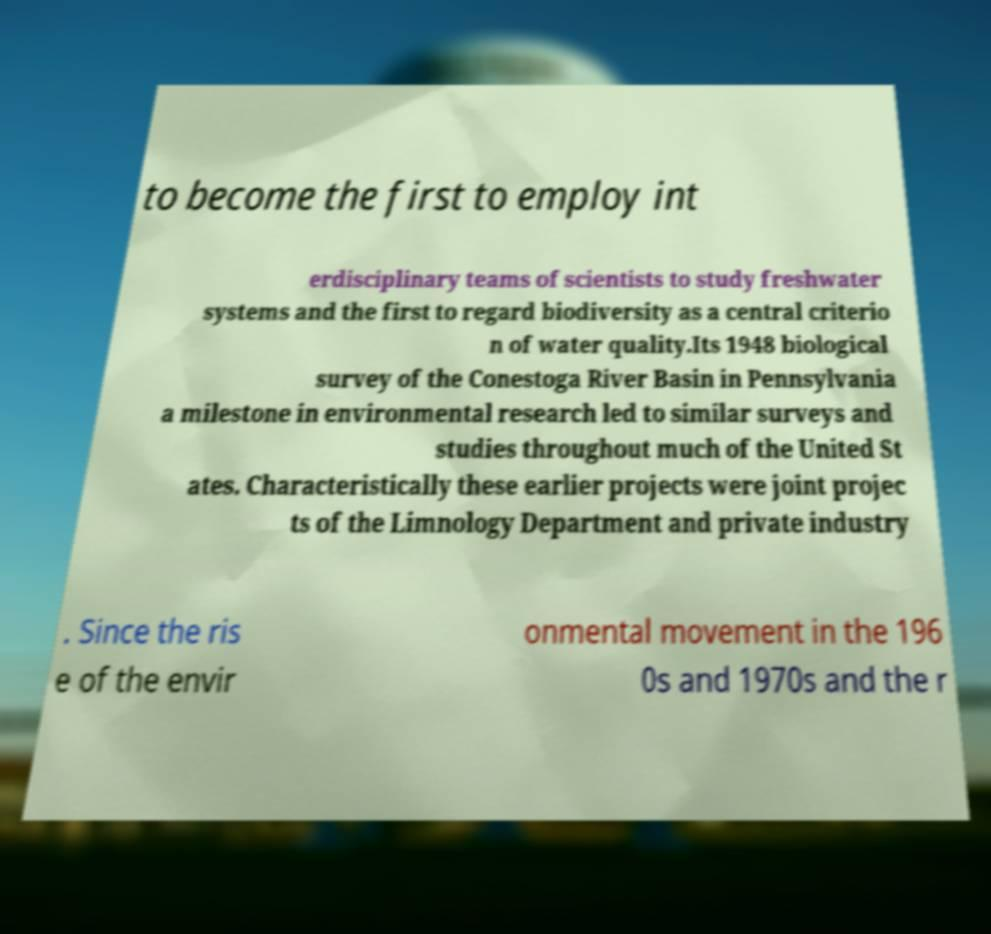Could you assist in decoding the text presented in this image and type it out clearly? to become the first to employ int erdisciplinary teams of scientists to study freshwater systems and the first to regard biodiversity as a central criterio n of water quality.Its 1948 biological survey of the Conestoga River Basin in Pennsylvania a milestone in environmental research led to similar surveys and studies throughout much of the United St ates. Characteristically these earlier projects were joint projec ts of the Limnology Department and private industry . Since the ris e of the envir onmental movement in the 196 0s and 1970s and the r 